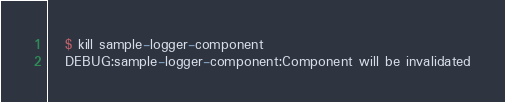Convert code to text. <code><loc_0><loc_0><loc_500><loc_500><_Python_>
   $ kill sample-logger-component
   DEBUG:sample-logger-component:Component will be invalidated</code> 